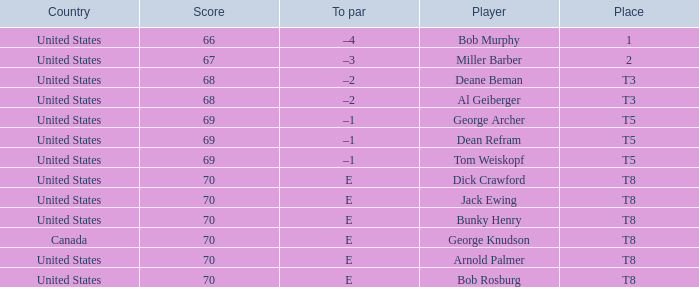When Bunky Henry of the United States scored higher than 68 and his To par was e, what was his place? T8. Would you mind parsing the complete table? {'header': ['Country', 'Score', 'To par', 'Player', 'Place'], 'rows': [['United States', '66', '–4', 'Bob Murphy', '1'], ['United States', '67', '–3', 'Miller Barber', '2'], ['United States', '68', '–2', 'Deane Beman', 'T3'], ['United States', '68', '–2', 'Al Geiberger', 'T3'], ['United States', '69', '–1', 'George Archer', 'T5'], ['United States', '69', '–1', 'Dean Refram', 'T5'], ['United States', '69', '–1', 'Tom Weiskopf', 'T5'], ['United States', '70', 'E', 'Dick Crawford', 'T8'], ['United States', '70', 'E', 'Jack Ewing', 'T8'], ['United States', '70', 'E', 'Bunky Henry', 'T8'], ['Canada', '70', 'E', 'George Knudson', 'T8'], ['United States', '70', 'E', 'Arnold Palmer', 'T8'], ['United States', '70', 'E', 'Bob Rosburg', 'T8']]} 